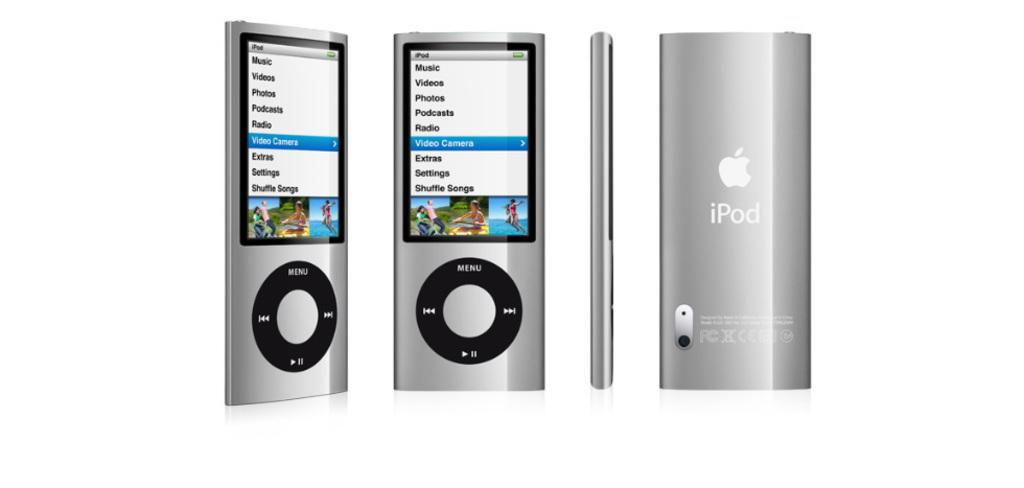<image>
Render a clear and concise summary of the photo. A group of Ipod shuffles displaying the menu screen 